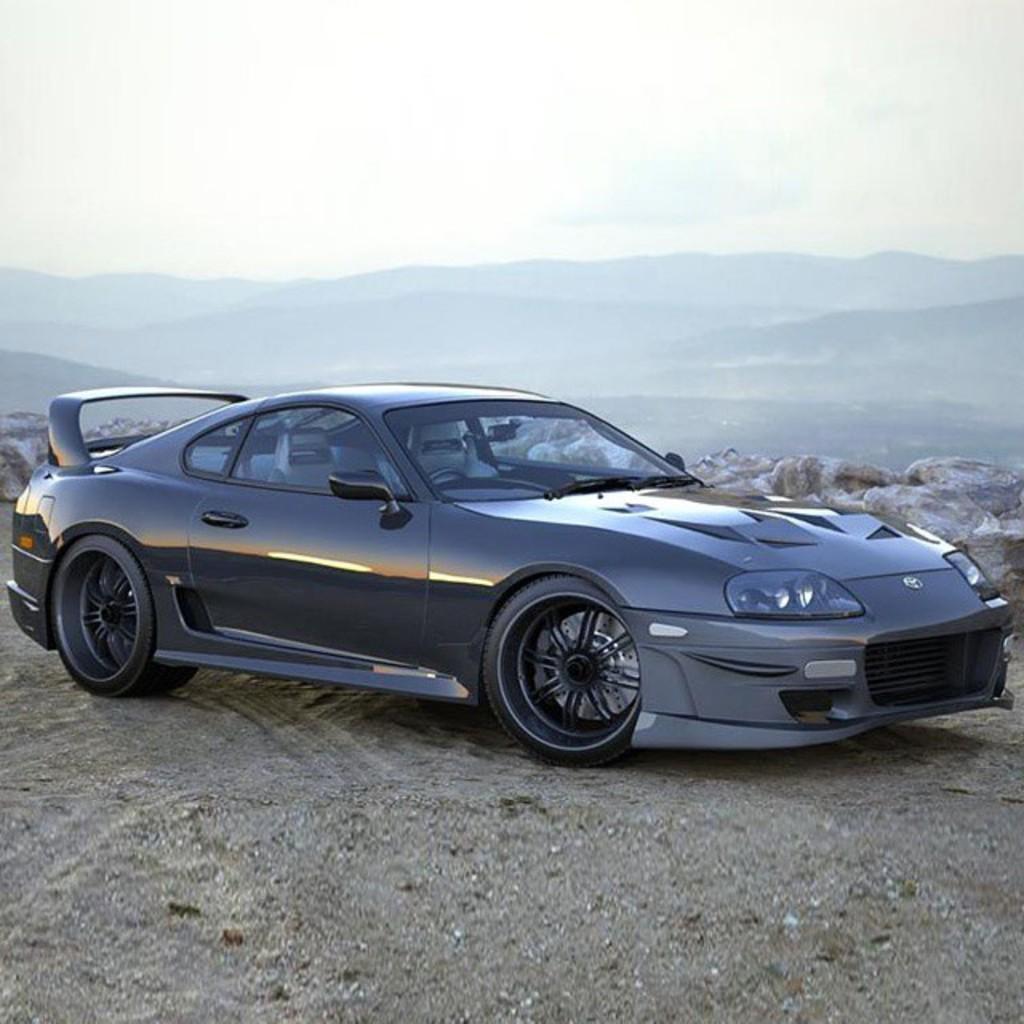Could you give a brief overview of what you see in this image? At the bottom of the image there is ground. In the middle of the ground there is a black car. Behind the car there are rocks. And in the background there are hills. At the top of the image there is a sky. 